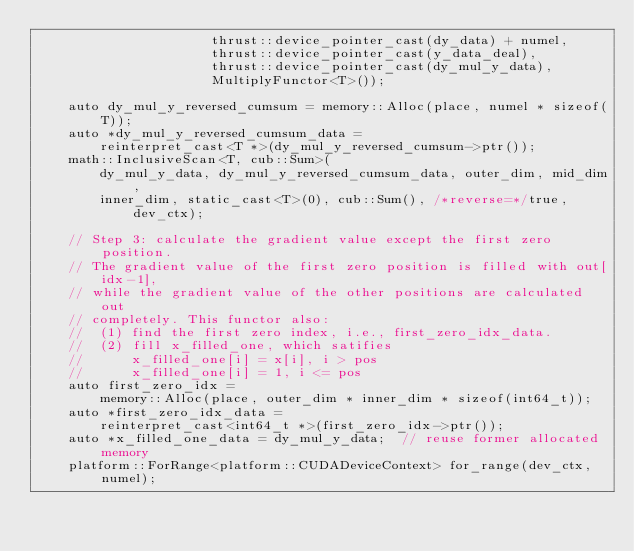<code> <loc_0><loc_0><loc_500><loc_500><_Cuda_>                      thrust::device_pointer_cast(dy_data) + numel,
                      thrust::device_pointer_cast(y_data_deal),
                      thrust::device_pointer_cast(dy_mul_y_data),
                      MultiplyFunctor<T>());

    auto dy_mul_y_reversed_cumsum = memory::Alloc(place, numel * sizeof(T));
    auto *dy_mul_y_reversed_cumsum_data =
        reinterpret_cast<T *>(dy_mul_y_reversed_cumsum->ptr());
    math::InclusiveScan<T, cub::Sum>(
        dy_mul_y_data, dy_mul_y_reversed_cumsum_data, outer_dim, mid_dim,
        inner_dim, static_cast<T>(0), cub::Sum(), /*reverse=*/true, dev_ctx);

    // Step 3: calculate the gradient value except the first zero position.
    // The gradient value of the first zero position is filled with out[idx-1],
    // while the gradient value of the other positions are calculated out
    // completely. This functor also:
    //  (1) find the first zero index, i.e., first_zero_idx_data.
    //  (2) fill x_filled_one, which satifies
    //      x_filled_one[i] = x[i], i > pos
    //      x_filled_one[i] = 1, i <= pos
    auto first_zero_idx =
        memory::Alloc(place, outer_dim * inner_dim * sizeof(int64_t));
    auto *first_zero_idx_data =
        reinterpret_cast<int64_t *>(first_zero_idx->ptr());
    auto *x_filled_one_data = dy_mul_y_data;  // reuse former allocated memory
    platform::ForRange<platform::CUDADeviceContext> for_range(dev_ctx, numel);</code> 